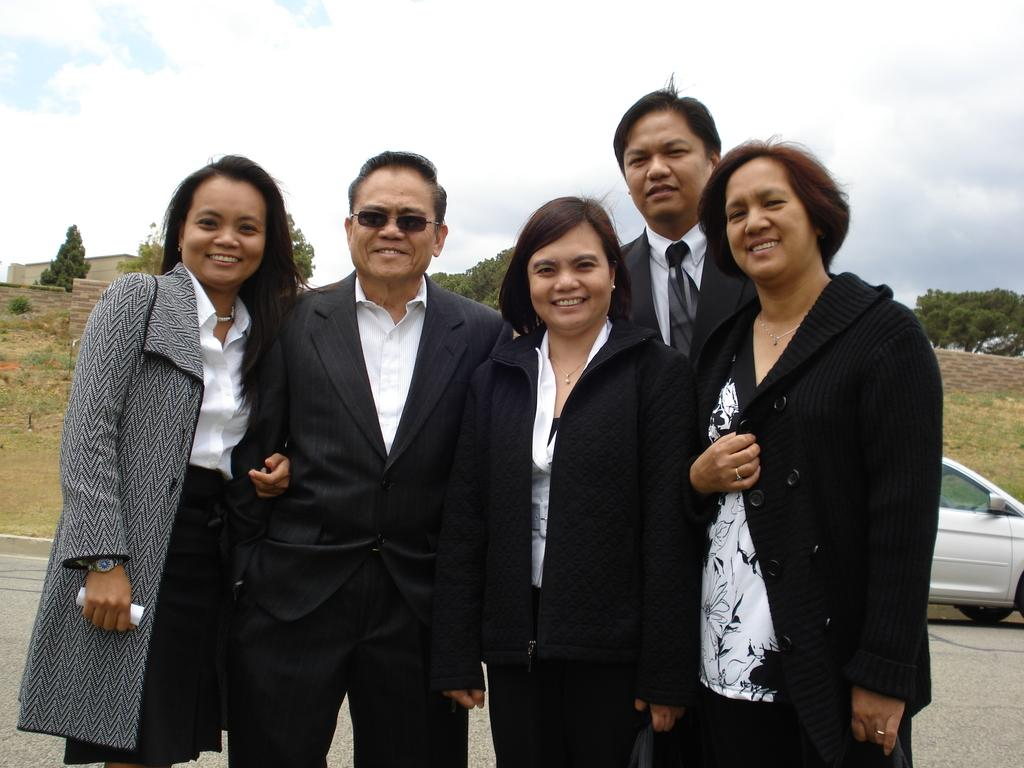How many people are in the image? There is a group of people in the image. What are the people doing in the image? The people are standing on the road and taking a picture. What can be seen in the background of the image? There is a vehicle, trees, and at least one building visible in the background. What is the weight of the donkey in the image? There is no donkey present in the image, so its weight cannot be determined. 